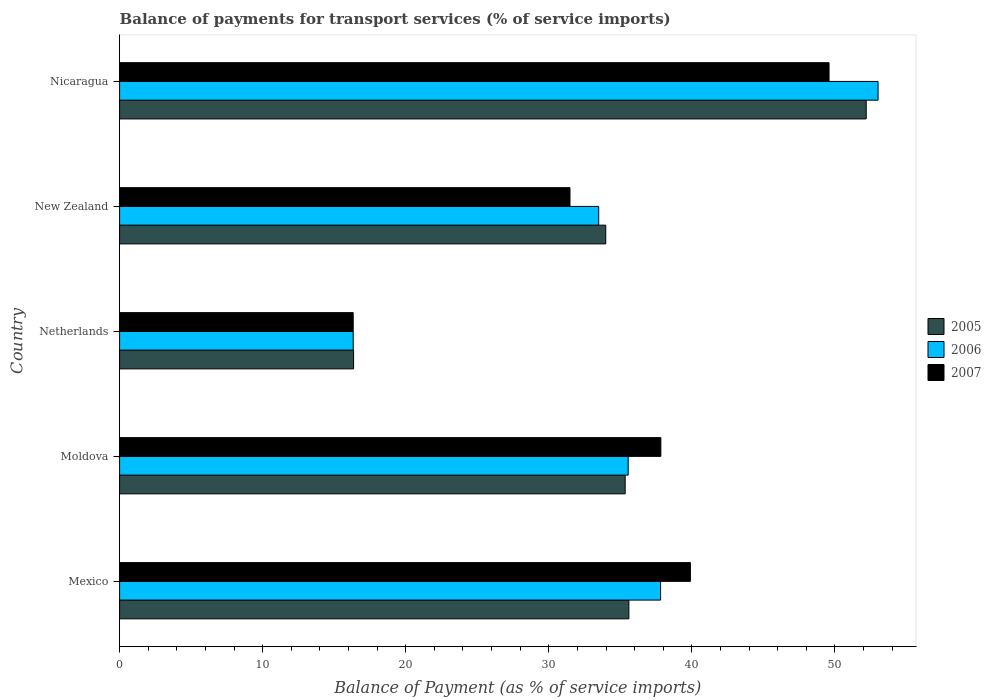How many different coloured bars are there?
Your response must be concise. 3. How many groups of bars are there?
Keep it short and to the point. 5. Are the number of bars on each tick of the Y-axis equal?
Your answer should be very brief. Yes. How many bars are there on the 2nd tick from the bottom?
Your answer should be compact. 3. What is the label of the 3rd group of bars from the top?
Provide a succinct answer. Netherlands. What is the balance of payments for transport services in 2007 in New Zealand?
Provide a short and direct response. 31.48. Across all countries, what is the maximum balance of payments for transport services in 2007?
Ensure brevity in your answer.  49.59. Across all countries, what is the minimum balance of payments for transport services in 2007?
Provide a short and direct response. 16.33. In which country was the balance of payments for transport services in 2005 maximum?
Provide a succinct answer. Nicaragua. In which country was the balance of payments for transport services in 2006 minimum?
Provide a short and direct response. Netherlands. What is the total balance of payments for transport services in 2006 in the graph?
Provide a succinct answer. 176.19. What is the difference between the balance of payments for transport services in 2006 in Netherlands and that in Nicaragua?
Ensure brevity in your answer.  -36.69. What is the difference between the balance of payments for transport services in 2005 in New Zealand and the balance of payments for transport services in 2007 in Mexico?
Give a very brief answer. -5.92. What is the average balance of payments for transport services in 2005 per country?
Your answer should be compact. 34.69. What is the difference between the balance of payments for transport services in 2006 and balance of payments for transport services in 2007 in Mexico?
Provide a short and direct response. -2.08. In how many countries, is the balance of payments for transport services in 2006 greater than 38 %?
Offer a very short reply. 1. What is the ratio of the balance of payments for transport services in 2005 in New Zealand to that in Nicaragua?
Provide a succinct answer. 0.65. Is the difference between the balance of payments for transport services in 2006 in Mexico and New Zealand greater than the difference between the balance of payments for transport services in 2007 in Mexico and New Zealand?
Your response must be concise. No. What is the difference between the highest and the second highest balance of payments for transport services in 2005?
Provide a succinct answer. 16.59. What is the difference between the highest and the lowest balance of payments for transport services in 2006?
Keep it short and to the point. 36.69. What does the 2nd bar from the bottom in Netherlands represents?
Keep it short and to the point. 2006. How many bars are there?
Your answer should be very brief. 15. Are all the bars in the graph horizontal?
Your answer should be very brief. Yes. How many countries are there in the graph?
Your answer should be very brief. 5. Are the values on the major ticks of X-axis written in scientific E-notation?
Make the answer very short. No. Does the graph contain grids?
Make the answer very short. No. How many legend labels are there?
Offer a very short reply. 3. What is the title of the graph?
Your answer should be compact. Balance of payments for transport services (% of service imports). Does "2008" appear as one of the legend labels in the graph?
Your answer should be very brief. No. What is the label or title of the X-axis?
Make the answer very short. Balance of Payment (as % of service imports). What is the label or title of the Y-axis?
Ensure brevity in your answer.  Country. What is the Balance of Payment (as % of service imports) of 2005 in Mexico?
Give a very brief answer. 35.6. What is the Balance of Payment (as % of service imports) of 2006 in Mexico?
Offer a very short reply. 37.81. What is the Balance of Payment (as % of service imports) of 2007 in Mexico?
Your response must be concise. 39.9. What is the Balance of Payment (as % of service imports) in 2005 in Moldova?
Offer a terse response. 35.34. What is the Balance of Payment (as % of service imports) of 2006 in Moldova?
Make the answer very short. 35.55. What is the Balance of Payment (as % of service imports) in 2007 in Moldova?
Your response must be concise. 37.83. What is the Balance of Payment (as % of service imports) of 2005 in Netherlands?
Make the answer very short. 16.35. What is the Balance of Payment (as % of service imports) in 2006 in Netherlands?
Ensure brevity in your answer.  16.33. What is the Balance of Payment (as % of service imports) of 2007 in Netherlands?
Your answer should be very brief. 16.33. What is the Balance of Payment (as % of service imports) in 2005 in New Zealand?
Offer a terse response. 33.98. What is the Balance of Payment (as % of service imports) of 2006 in New Zealand?
Give a very brief answer. 33.49. What is the Balance of Payment (as % of service imports) in 2007 in New Zealand?
Offer a terse response. 31.48. What is the Balance of Payment (as % of service imports) in 2005 in Nicaragua?
Keep it short and to the point. 52.19. What is the Balance of Payment (as % of service imports) in 2006 in Nicaragua?
Offer a terse response. 53.01. What is the Balance of Payment (as % of service imports) of 2007 in Nicaragua?
Ensure brevity in your answer.  49.59. Across all countries, what is the maximum Balance of Payment (as % of service imports) of 2005?
Give a very brief answer. 52.19. Across all countries, what is the maximum Balance of Payment (as % of service imports) of 2006?
Your answer should be compact. 53.01. Across all countries, what is the maximum Balance of Payment (as % of service imports) of 2007?
Make the answer very short. 49.59. Across all countries, what is the minimum Balance of Payment (as % of service imports) of 2005?
Ensure brevity in your answer.  16.35. Across all countries, what is the minimum Balance of Payment (as % of service imports) in 2006?
Provide a succinct answer. 16.33. Across all countries, what is the minimum Balance of Payment (as % of service imports) in 2007?
Provide a short and direct response. 16.33. What is the total Balance of Payment (as % of service imports) of 2005 in the graph?
Provide a succinct answer. 173.46. What is the total Balance of Payment (as % of service imports) in 2006 in the graph?
Offer a terse response. 176.19. What is the total Balance of Payment (as % of service imports) in 2007 in the graph?
Give a very brief answer. 175.13. What is the difference between the Balance of Payment (as % of service imports) of 2005 in Mexico and that in Moldova?
Make the answer very short. 0.26. What is the difference between the Balance of Payment (as % of service imports) in 2006 in Mexico and that in Moldova?
Offer a very short reply. 2.27. What is the difference between the Balance of Payment (as % of service imports) of 2007 in Mexico and that in Moldova?
Your answer should be compact. 2.06. What is the difference between the Balance of Payment (as % of service imports) of 2005 in Mexico and that in Netherlands?
Your response must be concise. 19.24. What is the difference between the Balance of Payment (as % of service imports) of 2006 in Mexico and that in Netherlands?
Your answer should be very brief. 21.48. What is the difference between the Balance of Payment (as % of service imports) of 2007 in Mexico and that in Netherlands?
Your response must be concise. 23.57. What is the difference between the Balance of Payment (as % of service imports) in 2005 in Mexico and that in New Zealand?
Provide a succinct answer. 1.62. What is the difference between the Balance of Payment (as % of service imports) of 2006 in Mexico and that in New Zealand?
Offer a terse response. 4.33. What is the difference between the Balance of Payment (as % of service imports) of 2007 in Mexico and that in New Zealand?
Your answer should be compact. 8.42. What is the difference between the Balance of Payment (as % of service imports) of 2005 in Mexico and that in Nicaragua?
Offer a very short reply. -16.59. What is the difference between the Balance of Payment (as % of service imports) of 2006 in Mexico and that in Nicaragua?
Your answer should be very brief. -15.2. What is the difference between the Balance of Payment (as % of service imports) in 2007 in Mexico and that in Nicaragua?
Your answer should be very brief. -9.69. What is the difference between the Balance of Payment (as % of service imports) of 2005 in Moldova and that in Netherlands?
Your response must be concise. 18.98. What is the difference between the Balance of Payment (as % of service imports) of 2006 in Moldova and that in Netherlands?
Make the answer very short. 19.22. What is the difference between the Balance of Payment (as % of service imports) in 2007 in Moldova and that in Netherlands?
Offer a terse response. 21.51. What is the difference between the Balance of Payment (as % of service imports) of 2005 in Moldova and that in New Zealand?
Your response must be concise. 1.36. What is the difference between the Balance of Payment (as % of service imports) of 2006 in Moldova and that in New Zealand?
Provide a short and direct response. 2.06. What is the difference between the Balance of Payment (as % of service imports) of 2007 in Moldova and that in New Zealand?
Ensure brevity in your answer.  6.35. What is the difference between the Balance of Payment (as % of service imports) of 2005 in Moldova and that in Nicaragua?
Ensure brevity in your answer.  -16.85. What is the difference between the Balance of Payment (as % of service imports) of 2006 in Moldova and that in Nicaragua?
Make the answer very short. -17.47. What is the difference between the Balance of Payment (as % of service imports) in 2007 in Moldova and that in Nicaragua?
Make the answer very short. -11.75. What is the difference between the Balance of Payment (as % of service imports) of 2005 in Netherlands and that in New Zealand?
Give a very brief answer. -17.63. What is the difference between the Balance of Payment (as % of service imports) in 2006 in Netherlands and that in New Zealand?
Make the answer very short. -17.16. What is the difference between the Balance of Payment (as % of service imports) in 2007 in Netherlands and that in New Zealand?
Your answer should be very brief. -15.15. What is the difference between the Balance of Payment (as % of service imports) of 2005 in Netherlands and that in Nicaragua?
Keep it short and to the point. -35.83. What is the difference between the Balance of Payment (as % of service imports) of 2006 in Netherlands and that in Nicaragua?
Your response must be concise. -36.69. What is the difference between the Balance of Payment (as % of service imports) in 2007 in Netherlands and that in Nicaragua?
Keep it short and to the point. -33.26. What is the difference between the Balance of Payment (as % of service imports) of 2005 in New Zealand and that in Nicaragua?
Your answer should be compact. -18.21. What is the difference between the Balance of Payment (as % of service imports) of 2006 in New Zealand and that in Nicaragua?
Provide a succinct answer. -19.53. What is the difference between the Balance of Payment (as % of service imports) of 2007 in New Zealand and that in Nicaragua?
Make the answer very short. -18.11. What is the difference between the Balance of Payment (as % of service imports) in 2005 in Mexico and the Balance of Payment (as % of service imports) in 2006 in Moldova?
Provide a succinct answer. 0.05. What is the difference between the Balance of Payment (as % of service imports) in 2005 in Mexico and the Balance of Payment (as % of service imports) in 2007 in Moldova?
Your response must be concise. -2.24. What is the difference between the Balance of Payment (as % of service imports) in 2006 in Mexico and the Balance of Payment (as % of service imports) in 2007 in Moldova?
Keep it short and to the point. -0.02. What is the difference between the Balance of Payment (as % of service imports) of 2005 in Mexico and the Balance of Payment (as % of service imports) of 2006 in Netherlands?
Ensure brevity in your answer.  19.27. What is the difference between the Balance of Payment (as % of service imports) in 2005 in Mexico and the Balance of Payment (as % of service imports) in 2007 in Netherlands?
Your answer should be very brief. 19.27. What is the difference between the Balance of Payment (as % of service imports) in 2006 in Mexico and the Balance of Payment (as % of service imports) in 2007 in Netherlands?
Your response must be concise. 21.49. What is the difference between the Balance of Payment (as % of service imports) in 2005 in Mexico and the Balance of Payment (as % of service imports) in 2006 in New Zealand?
Keep it short and to the point. 2.11. What is the difference between the Balance of Payment (as % of service imports) in 2005 in Mexico and the Balance of Payment (as % of service imports) in 2007 in New Zealand?
Keep it short and to the point. 4.12. What is the difference between the Balance of Payment (as % of service imports) of 2006 in Mexico and the Balance of Payment (as % of service imports) of 2007 in New Zealand?
Your answer should be compact. 6.33. What is the difference between the Balance of Payment (as % of service imports) of 2005 in Mexico and the Balance of Payment (as % of service imports) of 2006 in Nicaragua?
Your response must be concise. -17.42. What is the difference between the Balance of Payment (as % of service imports) in 2005 in Mexico and the Balance of Payment (as % of service imports) in 2007 in Nicaragua?
Your response must be concise. -13.99. What is the difference between the Balance of Payment (as % of service imports) of 2006 in Mexico and the Balance of Payment (as % of service imports) of 2007 in Nicaragua?
Offer a very short reply. -11.77. What is the difference between the Balance of Payment (as % of service imports) of 2005 in Moldova and the Balance of Payment (as % of service imports) of 2006 in Netherlands?
Your answer should be very brief. 19.01. What is the difference between the Balance of Payment (as % of service imports) in 2005 in Moldova and the Balance of Payment (as % of service imports) in 2007 in Netherlands?
Keep it short and to the point. 19.01. What is the difference between the Balance of Payment (as % of service imports) in 2006 in Moldova and the Balance of Payment (as % of service imports) in 2007 in Netherlands?
Give a very brief answer. 19.22. What is the difference between the Balance of Payment (as % of service imports) in 2005 in Moldova and the Balance of Payment (as % of service imports) in 2006 in New Zealand?
Provide a succinct answer. 1.85. What is the difference between the Balance of Payment (as % of service imports) of 2005 in Moldova and the Balance of Payment (as % of service imports) of 2007 in New Zealand?
Keep it short and to the point. 3.86. What is the difference between the Balance of Payment (as % of service imports) in 2006 in Moldova and the Balance of Payment (as % of service imports) in 2007 in New Zealand?
Keep it short and to the point. 4.07. What is the difference between the Balance of Payment (as % of service imports) in 2005 in Moldova and the Balance of Payment (as % of service imports) in 2006 in Nicaragua?
Your answer should be compact. -17.68. What is the difference between the Balance of Payment (as % of service imports) of 2005 in Moldova and the Balance of Payment (as % of service imports) of 2007 in Nicaragua?
Provide a short and direct response. -14.25. What is the difference between the Balance of Payment (as % of service imports) in 2006 in Moldova and the Balance of Payment (as % of service imports) in 2007 in Nicaragua?
Your response must be concise. -14.04. What is the difference between the Balance of Payment (as % of service imports) in 2005 in Netherlands and the Balance of Payment (as % of service imports) in 2006 in New Zealand?
Give a very brief answer. -17.13. What is the difference between the Balance of Payment (as % of service imports) in 2005 in Netherlands and the Balance of Payment (as % of service imports) in 2007 in New Zealand?
Give a very brief answer. -15.13. What is the difference between the Balance of Payment (as % of service imports) of 2006 in Netherlands and the Balance of Payment (as % of service imports) of 2007 in New Zealand?
Keep it short and to the point. -15.15. What is the difference between the Balance of Payment (as % of service imports) in 2005 in Netherlands and the Balance of Payment (as % of service imports) in 2006 in Nicaragua?
Make the answer very short. -36.66. What is the difference between the Balance of Payment (as % of service imports) in 2005 in Netherlands and the Balance of Payment (as % of service imports) in 2007 in Nicaragua?
Give a very brief answer. -33.23. What is the difference between the Balance of Payment (as % of service imports) of 2006 in Netherlands and the Balance of Payment (as % of service imports) of 2007 in Nicaragua?
Make the answer very short. -33.26. What is the difference between the Balance of Payment (as % of service imports) of 2005 in New Zealand and the Balance of Payment (as % of service imports) of 2006 in Nicaragua?
Your answer should be compact. -19.03. What is the difference between the Balance of Payment (as % of service imports) in 2005 in New Zealand and the Balance of Payment (as % of service imports) in 2007 in Nicaragua?
Your answer should be compact. -15.61. What is the difference between the Balance of Payment (as % of service imports) in 2006 in New Zealand and the Balance of Payment (as % of service imports) in 2007 in Nicaragua?
Your answer should be compact. -16.1. What is the average Balance of Payment (as % of service imports) of 2005 per country?
Give a very brief answer. 34.69. What is the average Balance of Payment (as % of service imports) in 2006 per country?
Make the answer very short. 35.24. What is the average Balance of Payment (as % of service imports) in 2007 per country?
Give a very brief answer. 35.03. What is the difference between the Balance of Payment (as % of service imports) in 2005 and Balance of Payment (as % of service imports) in 2006 in Mexico?
Your answer should be very brief. -2.22. What is the difference between the Balance of Payment (as % of service imports) of 2005 and Balance of Payment (as % of service imports) of 2007 in Mexico?
Provide a short and direct response. -4.3. What is the difference between the Balance of Payment (as % of service imports) of 2006 and Balance of Payment (as % of service imports) of 2007 in Mexico?
Provide a short and direct response. -2.08. What is the difference between the Balance of Payment (as % of service imports) in 2005 and Balance of Payment (as % of service imports) in 2006 in Moldova?
Offer a terse response. -0.21. What is the difference between the Balance of Payment (as % of service imports) of 2005 and Balance of Payment (as % of service imports) of 2007 in Moldova?
Your answer should be very brief. -2.49. What is the difference between the Balance of Payment (as % of service imports) in 2006 and Balance of Payment (as % of service imports) in 2007 in Moldova?
Your response must be concise. -2.29. What is the difference between the Balance of Payment (as % of service imports) in 2005 and Balance of Payment (as % of service imports) in 2006 in Netherlands?
Keep it short and to the point. 0.03. What is the difference between the Balance of Payment (as % of service imports) of 2005 and Balance of Payment (as % of service imports) of 2007 in Netherlands?
Keep it short and to the point. 0.03. What is the difference between the Balance of Payment (as % of service imports) in 2006 and Balance of Payment (as % of service imports) in 2007 in Netherlands?
Your answer should be compact. 0. What is the difference between the Balance of Payment (as % of service imports) in 2005 and Balance of Payment (as % of service imports) in 2006 in New Zealand?
Make the answer very short. 0.49. What is the difference between the Balance of Payment (as % of service imports) in 2005 and Balance of Payment (as % of service imports) in 2007 in New Zealand?
Your response must be concise. 2.5. What is the difference between the Balance of Payment (as % of service imports) of 2006 and Balance of Payment (as % of service imports) of 2007 in New Zealand?
Keep it short and to the point. 2.01. What is the difference between the Balance of Payment (as % of service imports) in 2005 and Balance of Payment (as % of service imports) in 2006 in Nicaragua?
Your answer should be very brief. -0.83. What is the difference between the Balance of Payment (as % of service imports) of 2005 and Balance of Payment (as % of service imports) of 2007 in Nicaragua?
Offer a terse response. 2.6. What is the difference between the Balance of Payment (as % of service imports) in 2006 and Balance of Payment (as % of service imports) in 2007 in Nicaragua?
Give a very brief answer. 3.43. What is the ratio of the Balance of Payment (as % of service imports) of 2005 in Mexico to that in Moldova?
Give a very brief answer. 1.01. What is the ratio of the Balance of Payment (as % of service imports) in 2006 in Mexico to that in Moldova?
Offer a very short reply. 1.06. What is the ratio of the Balance of Payment (as % of service imports) of 2007 in Mexico to that in Moldova?
Offer a very short reply. 1.05. What is the ratio of the Balance of Payment (as % of service imports) in 2005 in Mexico to that in Netherlands?
Give a very brief answer. 2.18. What is the ratio of the Balance of Payment (as % of service imports) of 2006 in Mexico to that in Netherlands?
Your answer should be very brief. 2.32. What is the ratio of the Balance of Payment (as % of service imports) in 2007 in Mexico to that in Netherlands?
Keep it short and to the point. 2.44. What is the ratio of the Balance of Payment (as % of service imports) of 2005 in Mexico to that in New Zealand?
Your answer should be very brief. 1.05. What is the ratio of the Balance of Payment (as % of service imports) in 2006 in Mexico to that in New Zealand?
Your response must be concise. 1.13. What is the ratio of the Balance of Payment (as % of service imports) in 2007 in Mexico to that in New Zealand?
Provide a short and direct response. 1.27. What is the ratio of the Balance of Payment (as % of service imports) in 2005 in Mexico to that in Nicaragua?
Your answer should be very brief. 0.68. What is the ratio of the Balance of Payment (as % of service imports) in 2006 in Mexico to that in Nicaragua?
Keep it short and to the point. 0.71. What is the ratio of the Balance of Payment (as % of service imports) of 2007 in Mexico to that in Nicaragua?
Provide a short and direct response. 0.8. What is the ratio of the Balance of Payment (as % of service imports) in 2005 in Moldova to that in Netherlands?
Give a very brief answer. 2.16. What is the ratio of the Balance of Payment (as % of service imports) of 2006 in Moldova to that in Netherlands?
Offer a very short reply. 2.18. What is the ratio of the Balance of Payment (as % of service imports) of 2007 in Moldova to that in Netherlands?
Provide a succinct answer. 2.32. What is the ratio of the Balance of Payment (as % of service imports) of 2006 in Moldova to that in New Zealand?
Your response must be concise. 1.06. What is the ratio of the Balance of Payment (as % of service imports) in 2007 in Moldova to that in New Zealand?
Provide a short and direct response. 1.2. What is the ratio of the Balance of Payment (as % of service imports) of 2005 in Moldova to that in Nicaragua?
Your response must be concise. 0.68. What is the ratio of the Balance of Payment (as % of service imports) of 2006 in Moldova to that in Nicaragua?
Provide a short and direct response. 0.67. What is the ratio of the Balance of Payment (as % of service imports) in 2007 in Moldova to that in Nicaragua?
Your response must be concise. 0.76. What is the ratio of the Balance of Payment (as % of service imports) in 2005 in Netherlands to that in New Zealand?
Offer a very short reply. 0.48. What is the ratio of the Balance of Payment (as % of service imports) of 2006 in Netherlands to that in New Zealand?
Your answer should be compact. 0.49. What is the ratio of the Balance of Payment (as % of service imports) in 2007 in Netherlands to that in New Zealand?
Your answer should be very brief. 0.52. What is the ratio of the Balance of Payment (as % of service imports) in 2005 in Netherlands to that in Nicaragua?
Give a very brief answer. 0.31. What is the ratio of the Balance of Payment (as % of service imports) of 2006 in Netherlands to that in Nicaragua?
Keep it short and to the point. 0.31. What is the ratio of the Balance of Payment (as % of service imports) of 2007 in Netherlands to that in Nicaragua?
Your response must be concise. 0.33. What is the ratio of the Balance of Payment (as % of service imports) in 2005 in New Zealand to that in Nicaragua?
Give a very brief answer. 0.65. What is the ratio of the Balance of Payment (as % of service imports) in 2006 in New Zealand to that in Nicaragua?
Ensure brevity in your answer.  0.63. What is the ratio of the Balance of Payment (as % of service imports) in 2007 in New Zealand to that in Nicaragua?
Provide a succinct answer. 0.63. What is the difference between the highest and the second highest Balance of Payment (as % of service imports) in 2005?
Keep it short and to the point. 16.59. What is the difference between the highest and the second highest Balance of Payment (as % of service imports) in 2006?
Keep it short and to the point. 15.2. What is the difference between the highest and the second highest Balance of Payment (as % of service imports) in 2007?
Keep it short and to the point. 9.69. What is the difference between the highest and the lowest Balance of Payment (as % of service imports) in 2005?
Your response must be concise. 35.83. What is the difference between the highest and the lowest Balance of Payment (as % of service imports) in 2006?
Your answer should be compact. 36.69. What is the difference between the highest and the lowest Balance of Payment (as % of service imports) of 2007?
Offer a terse response. 33.26. 